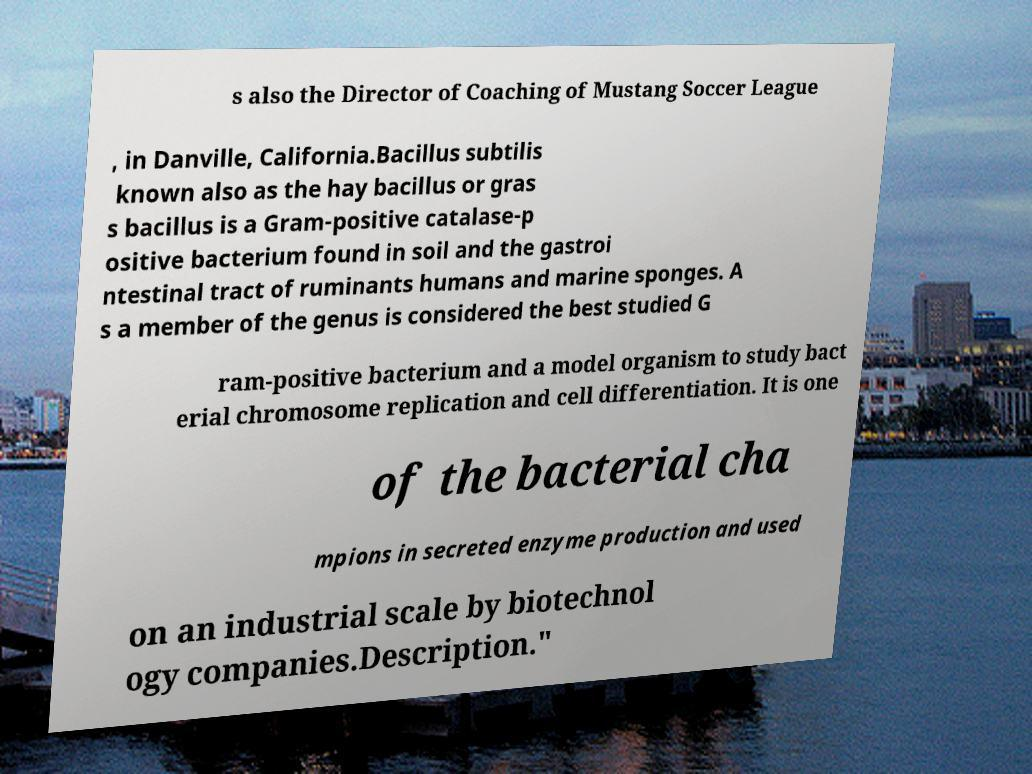For documentation purposes, I need the text within this image transcribed. Could you provide that? s also the Director of Coaching of Mustang Soccer League , in Danville, California.Bacillus subtilis known also as the hay bacillus or gras s bacillus is a Gram-positive catalase-p ositive bacterium found in soil and the gastroi ntestinal tract of ruminants humans and marine sponges. A s a member of the genus is considered the best studied G ram-positive bacterium and a model organism to study bact erial chromosome replication and cell differentiation. It is one of the bacterial cha mpions in secreted enzyme production and used on an industrial scale by biotechnol ogy companies.Description." 